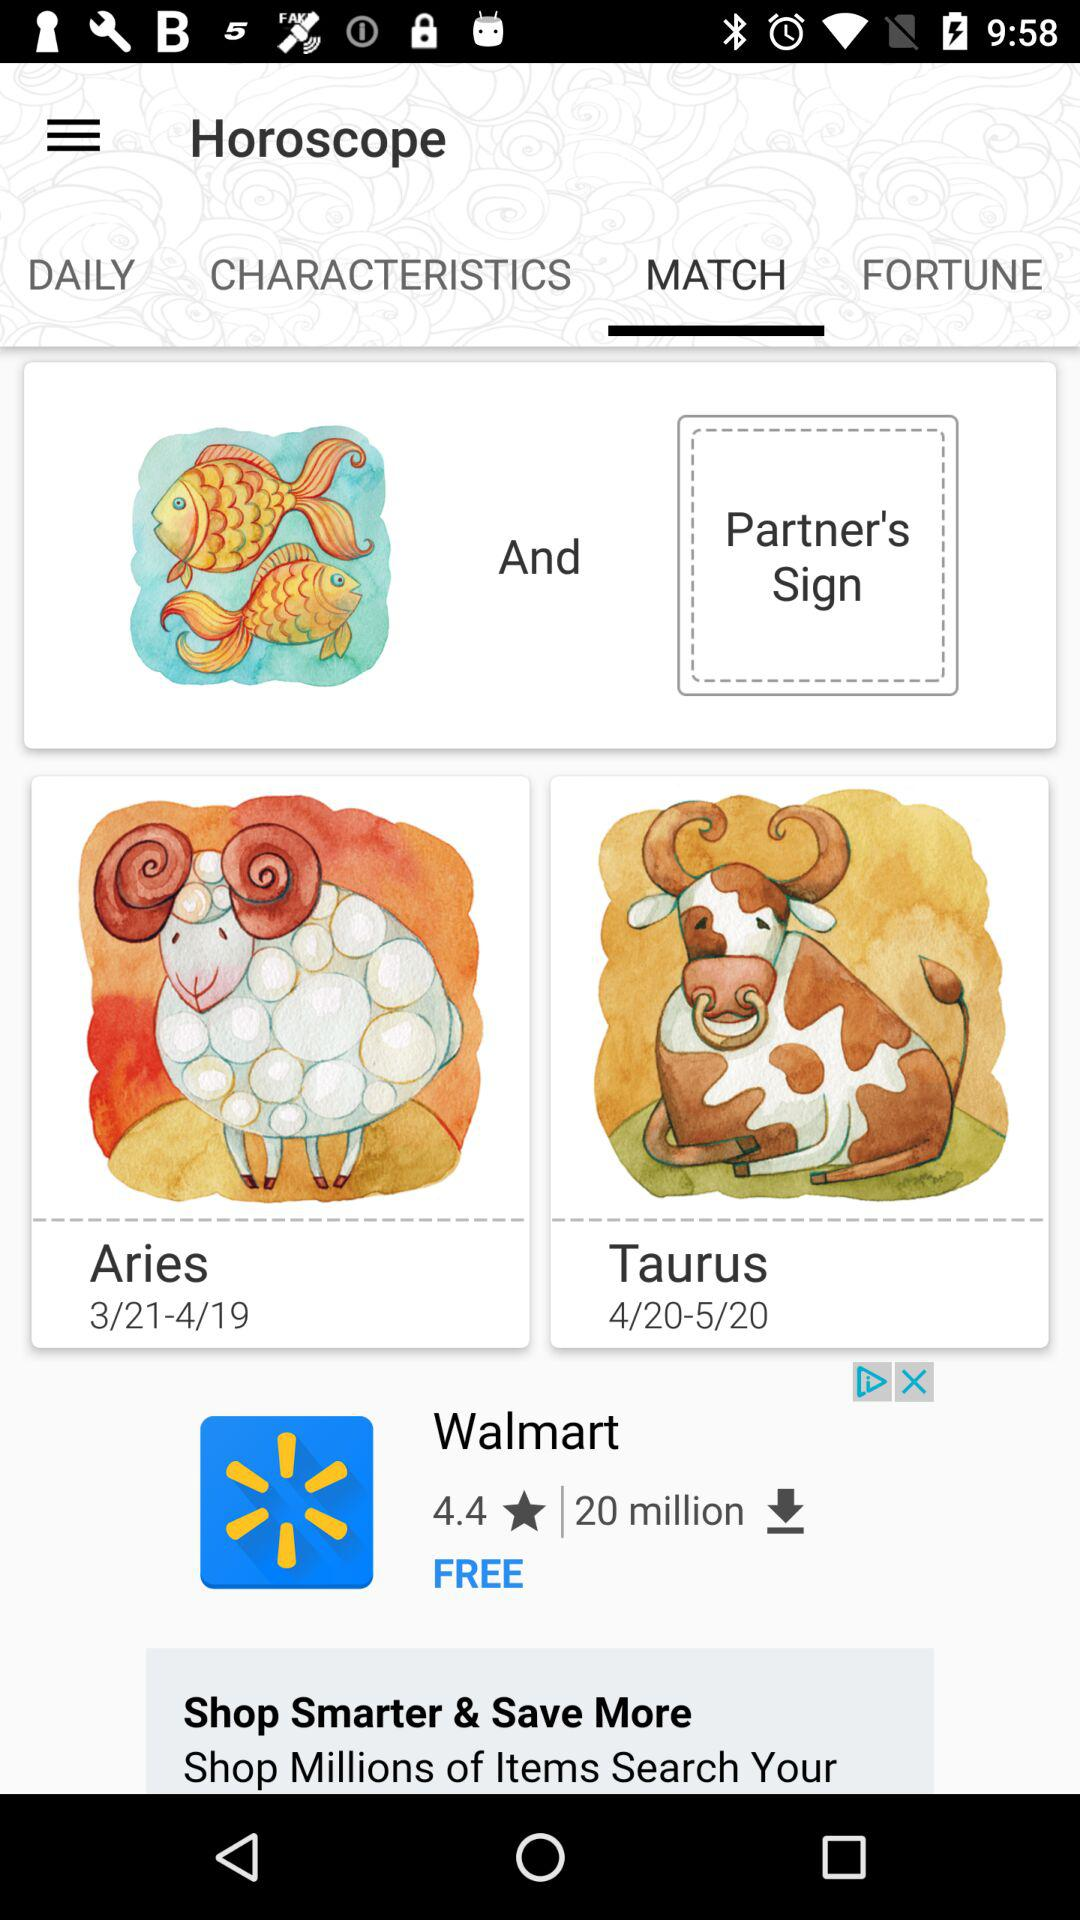Which tab is selected? The selected tab is "MATCH". 